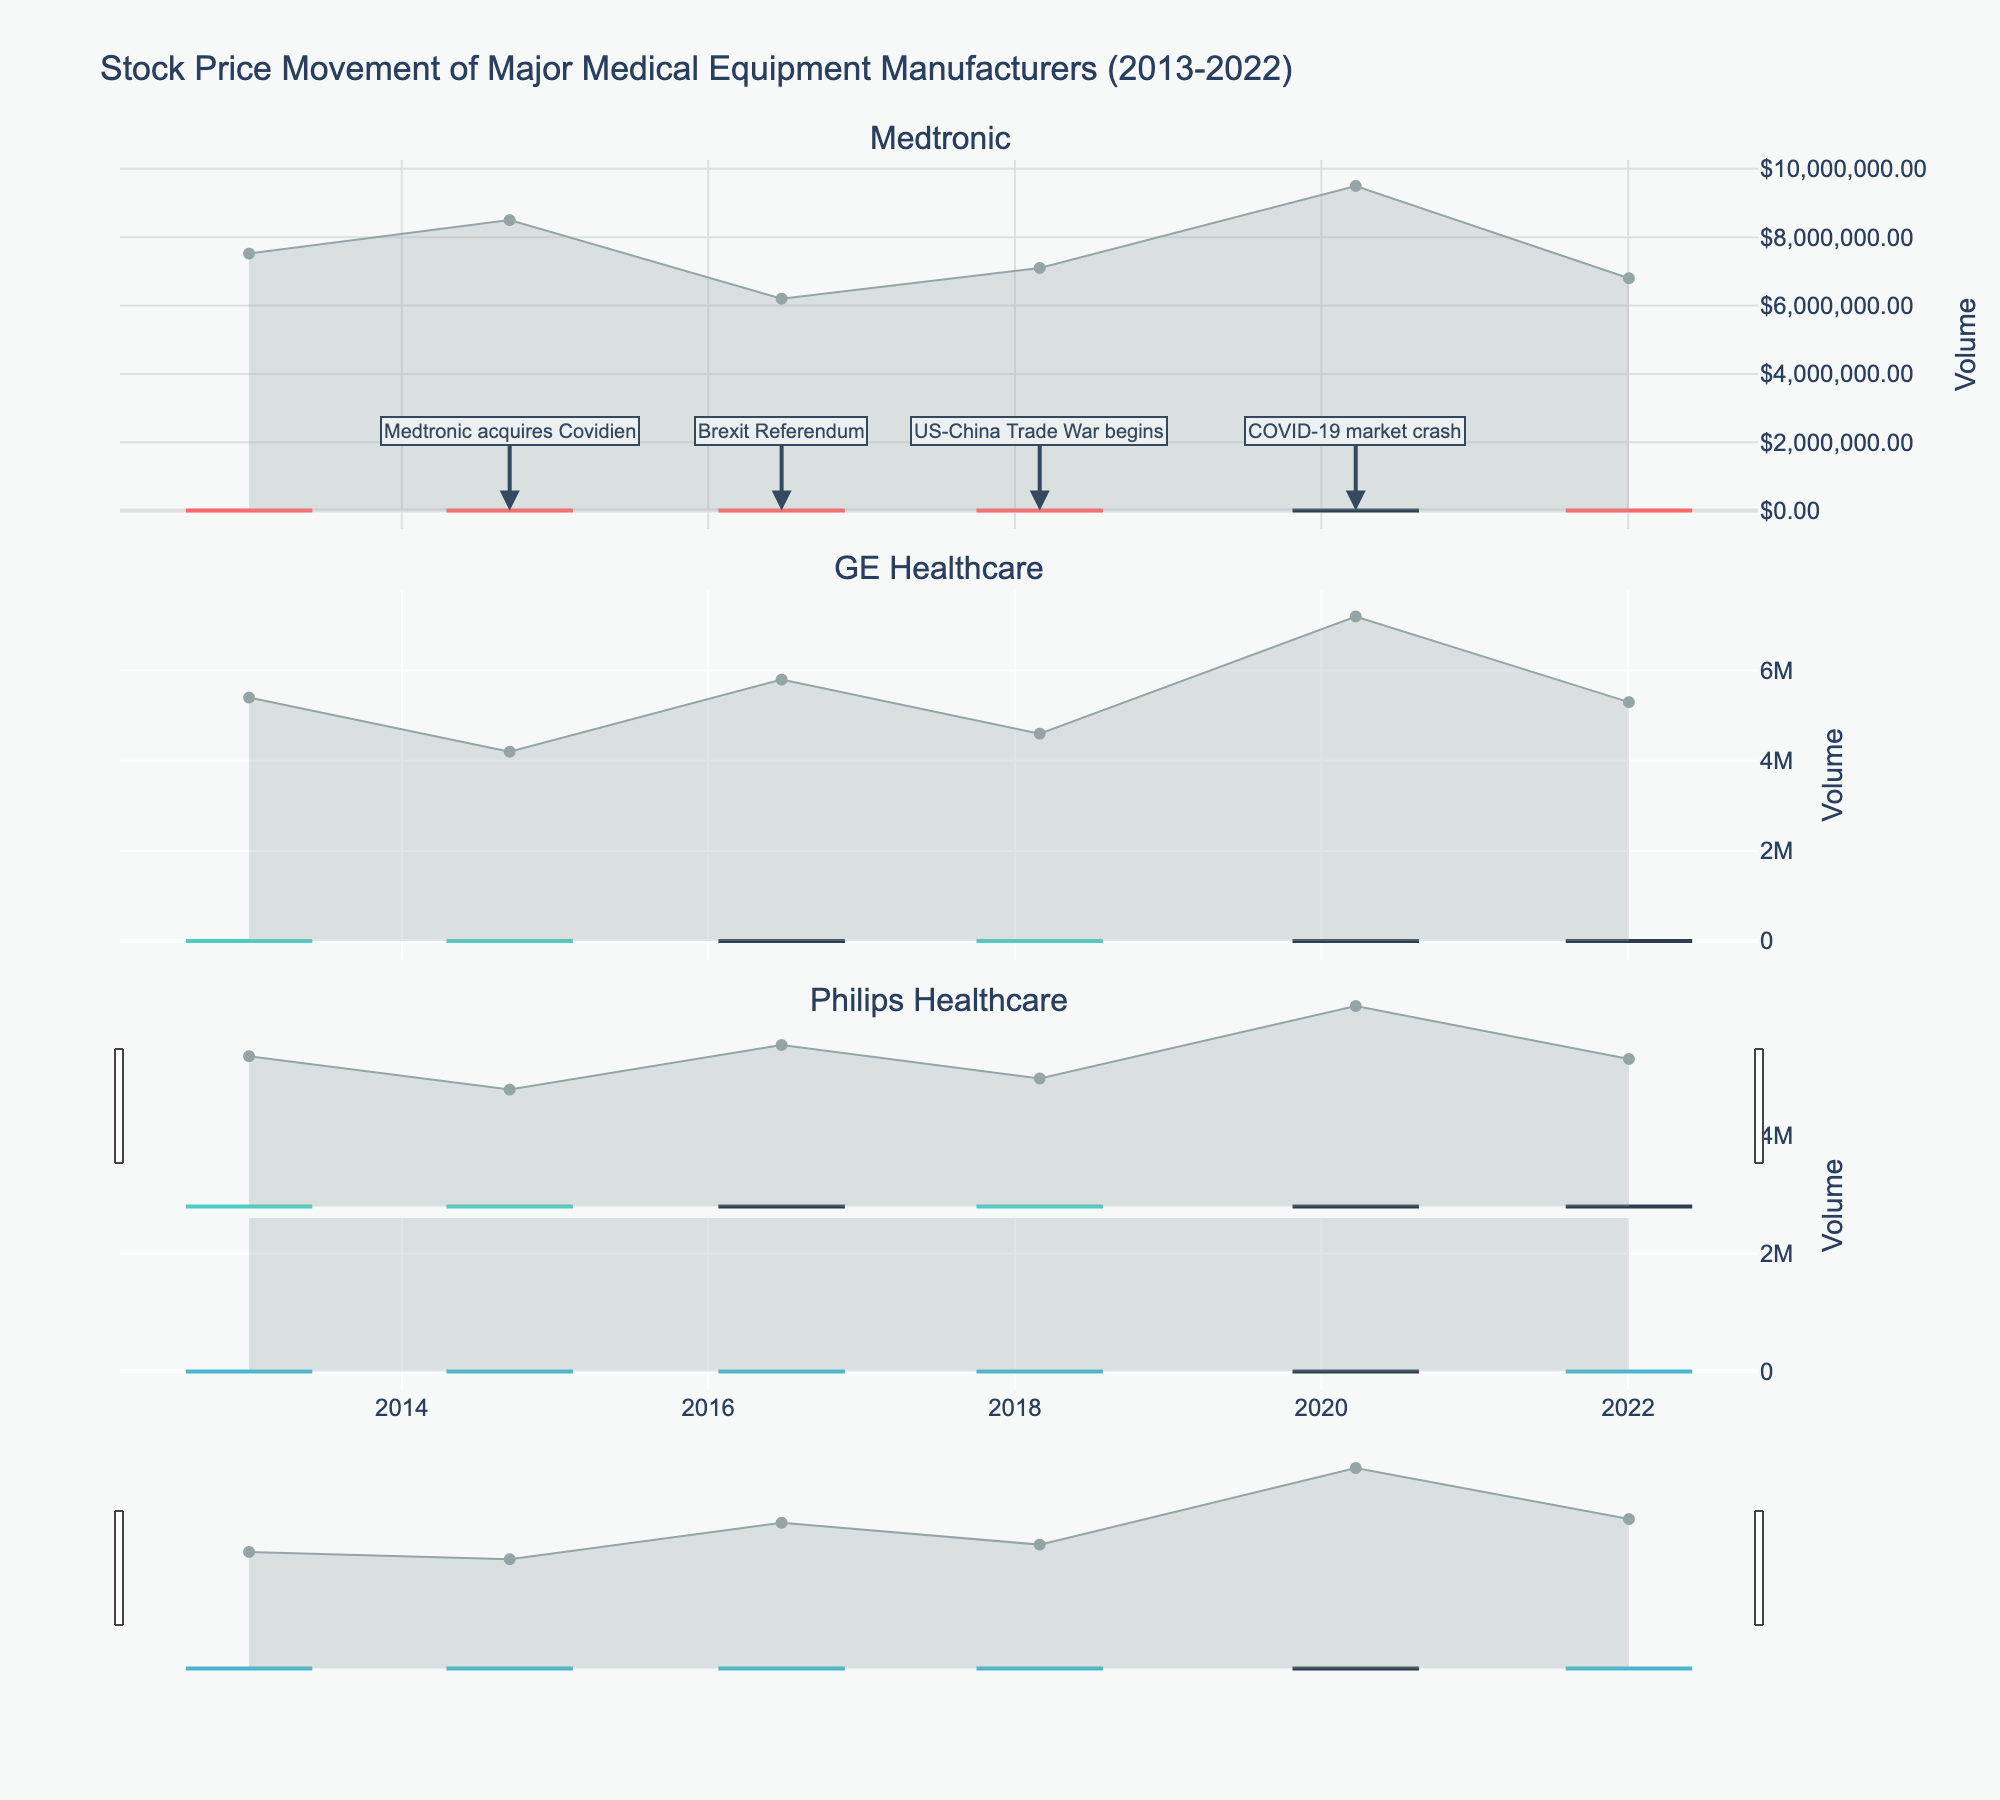Which company's stock price had the highest value on January 3, 2022? Look at the candlestick representing January 3, 2022, for each company and compare their "High" prices. Medtronic has the highest value of 109.50.
Answer: Medtronic What significant event occurred on June 24, 2016, and how might it have impacted the stock prices? Identify the annotation on June 24, 2016, indicating the "Brexit Referendum." Check the candlestick around this date to judge the immediate reactions. The stock prices have visible volatility.
Answer: Brexit Referendum; Volatility How did Philips Healthcare's stock price change from January 2, 2013, to January 3, 2022? Compare the "Close" price on January 2, 2013 (26.90), with the "Close" price on January 3, 2022 (45.80). The price increased.
Answer: Increased Which company had the highest trading volume on March 23, 2020? Look at the volume subplot for each company on March 23, 2020. Medtronic has the highest volume of 9,500,000.
Answer: Medtronic On what date did Medtronic's stock price first exceed $100 in your dataset? Check the 'High' prices for Medtronic and find the first date it exceeded $100, which is January 3, 2022.
Answer: January 3, 2022 How did the US-China Trade War impact GE Healthcare's stock price observed on March 1, 2018? Observe the annotation dated March 1, 2018, related to the US-China Trade War and the candlestick for GE Healthcare. Understand the potential impact by looking at how the stock price behaved on that date. The price increased.
Answer: Increased Did Philips Healthcare's stock price increase or decrease due to the COVID-19 market crash on March 23, 2020? Check the close price prior to March 23, 2020, and compare it to the close price on March 23, 2020 (37.90). It decreased from the previous close.
Answer: Decreased How does the volatility of Medtronic's stock prices around significant economic events compare to GE Healthcare's? Identify the volatility in the candlesticks for dates marked with significant events (annotations), and compare the range of highs and lows of Medtronic's candles to those of GE Healthcare.
Answer: Medtronic has higher volatility How did Medtronic’s acquisition of Covidien on September 15, 2014, influence its stock price? Look at the candlestick data around September 15, 2014, and see if there's a noticeable change. There is an increase on that date.
Answer: Increased 